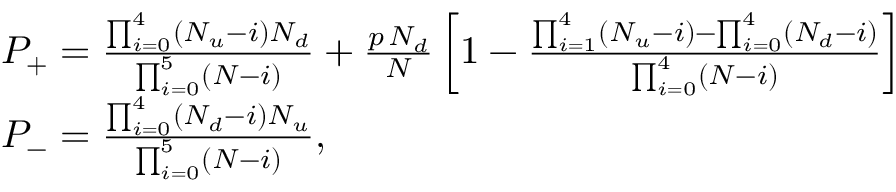Convert formula to latex. <formula><loc_0><loc_0><loc_500><loc_500>\begin{array} { r l } & { P _ { + } = \frac { \prod _ { i = 0 } ^ { 4 } \left ( N _ { u } - i \right ) N _ { d } } { \prod _ { i = 0 } ^ { 5 } \left ( N - i \right ) } + \frac { p \, N _ { d } } { N } \left [ 1 - \frac { \prod _ { i = 1 } ^ { 4 } \left ( N _ { u } - i \right ) - \prod _ { i = 0 } ^ { 4 } \left ( N _ { d } - i \right ) } { \prod _ { i = 0 } ^ { 4 } \left ( N - i \right ) } \right ] } \\ & { P _ { - } = \frac { \prod _ { i = 0 } ^ { 4 } \left ( N _ { d } - i \right ) N _ { u } } { \prod _ { i = 0 } ^ { 5 } \left ( N - i \right ) } , } \end{array}</formula> 